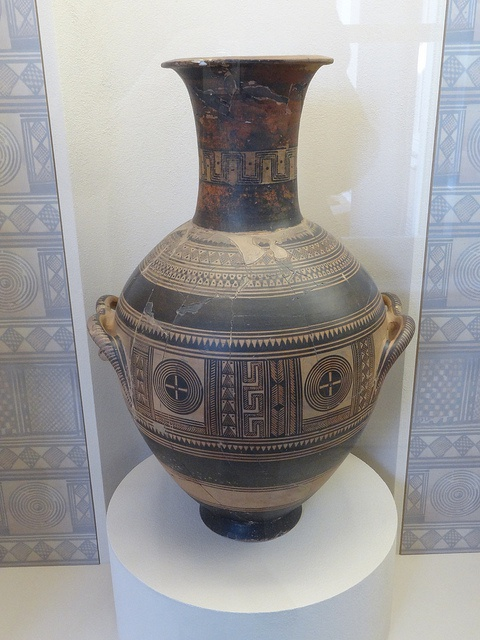Describe the objects in this image and their specific colors. I can see a vase in darkgray, gray, and black tones in this image. 